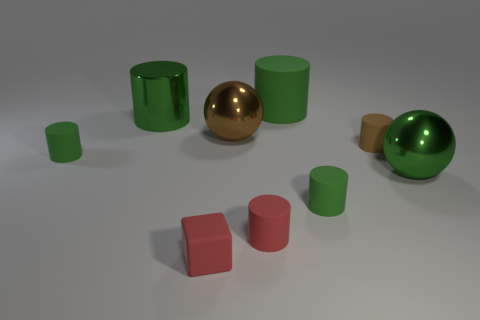How many cylinders are brown things or metallic things?
Offer a very short reply. 2. There is a big brown thing; is its shape the same as the large green object that is right of the small brown matte object?
Your response must be concise. Yes. There is a green matte cylinder that is in front of the large green metallic cylinder and on the right side of the red matte cube; how big is it?
Make the answer very short. Small. The big brown metal object has what shape?
Your answer should be very brief. Sphere. Are there any large green metal spheres on the left side of the large green metallic thing that is behind the big green metal ball?
Your response must be concise. No. What number of large brown metal spheres are on the left side of the small green cylinder that is to the left of the big rubber cylinder?
Your response must be concise. 0. What material is the brown thing that is the same size as the red cube?
Your response must be concise. Rubber. There is a tiny green matte object that is behind the large green ball; does it have the same shape as the small brown object?
Make the answer very short. Yes. Is the number of balls that are in front of the red cube greater than the number of green matte things that are behind the small brown rubber cylinder?
Make the answer very short. No. What number of brown cylinders are the same material as the red block?
Make the answer very short. 1. 